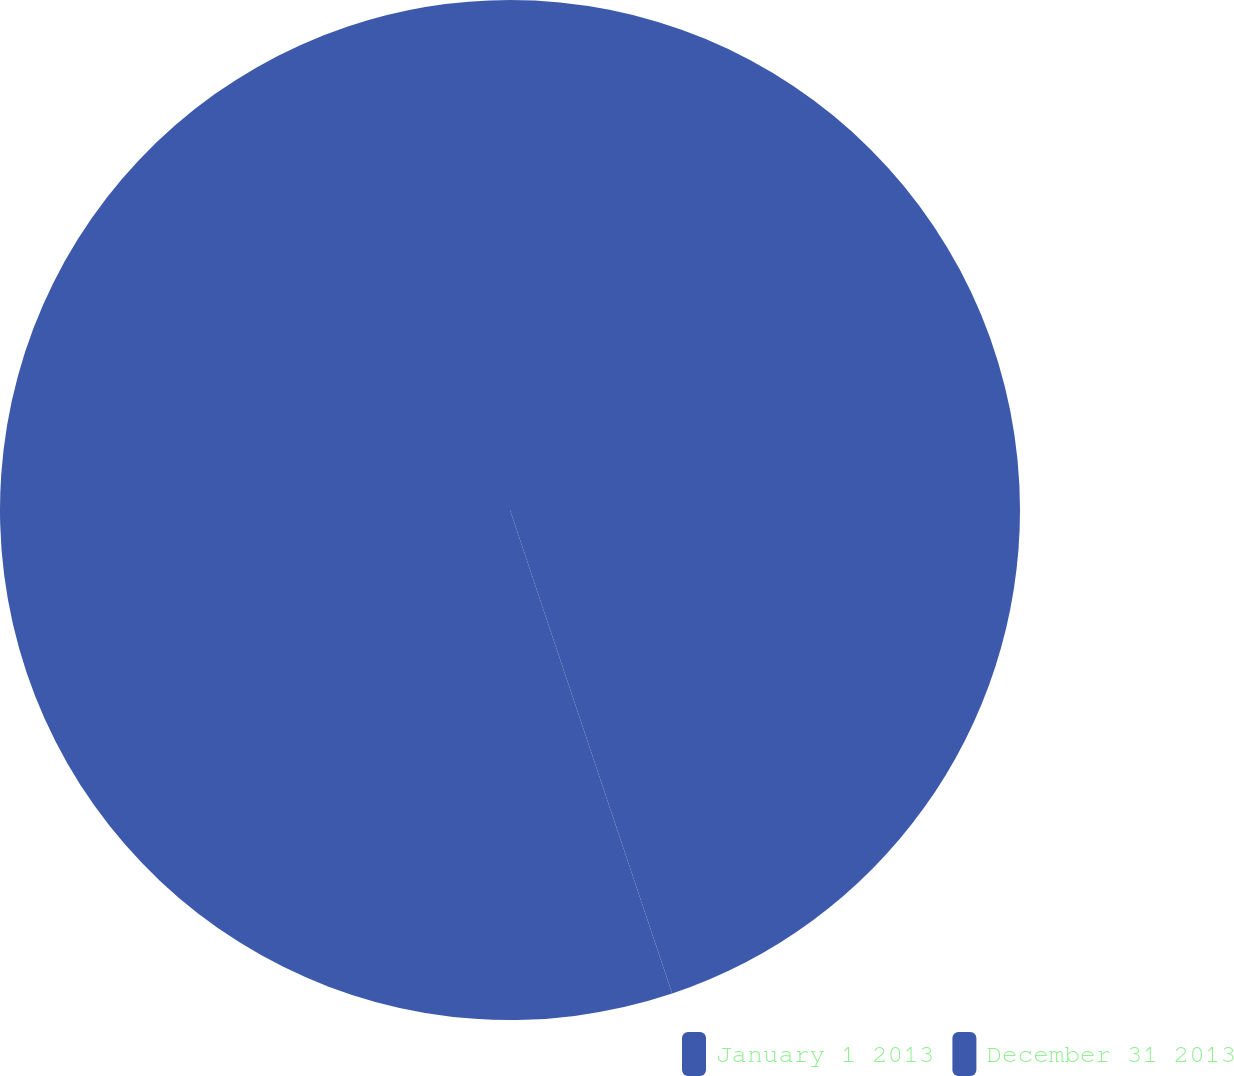Convert chart to OTSL. <chart><loc_0><loc_0><loc_500><loc_500><pie_chart><fcel>January 1 2013<fcel>December 31 2013<nl><fcel>44.85%<fcel>55.15%<nl></chart> 